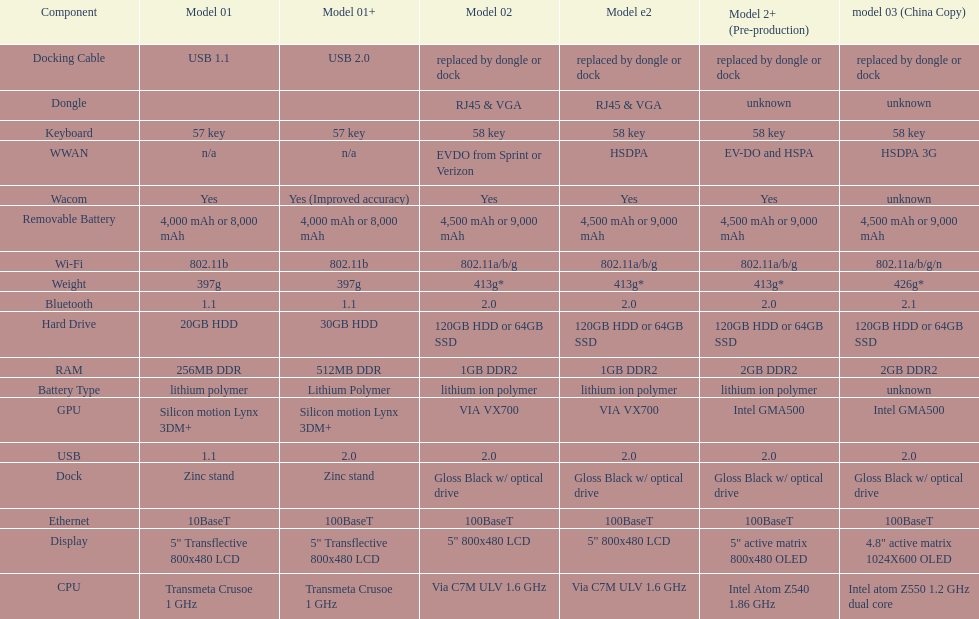What component comes after bluetooth? Wacom. 